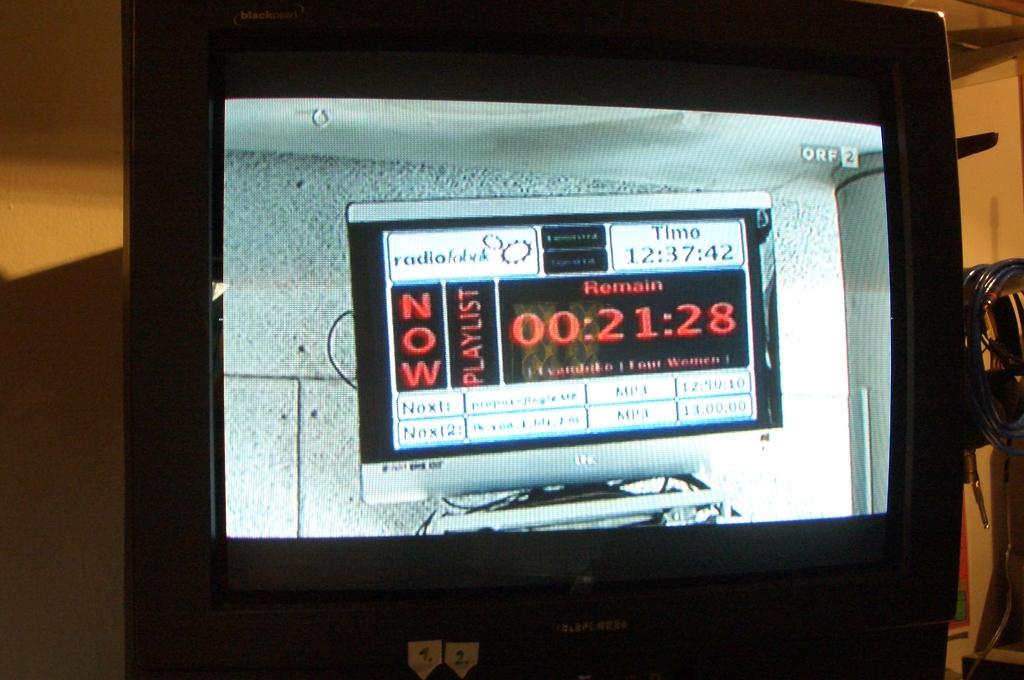What time is shown under the heading time?
Provide a short and direct response. 12:37:42. What is the time?
Make the answer very short. 12:37:42. 